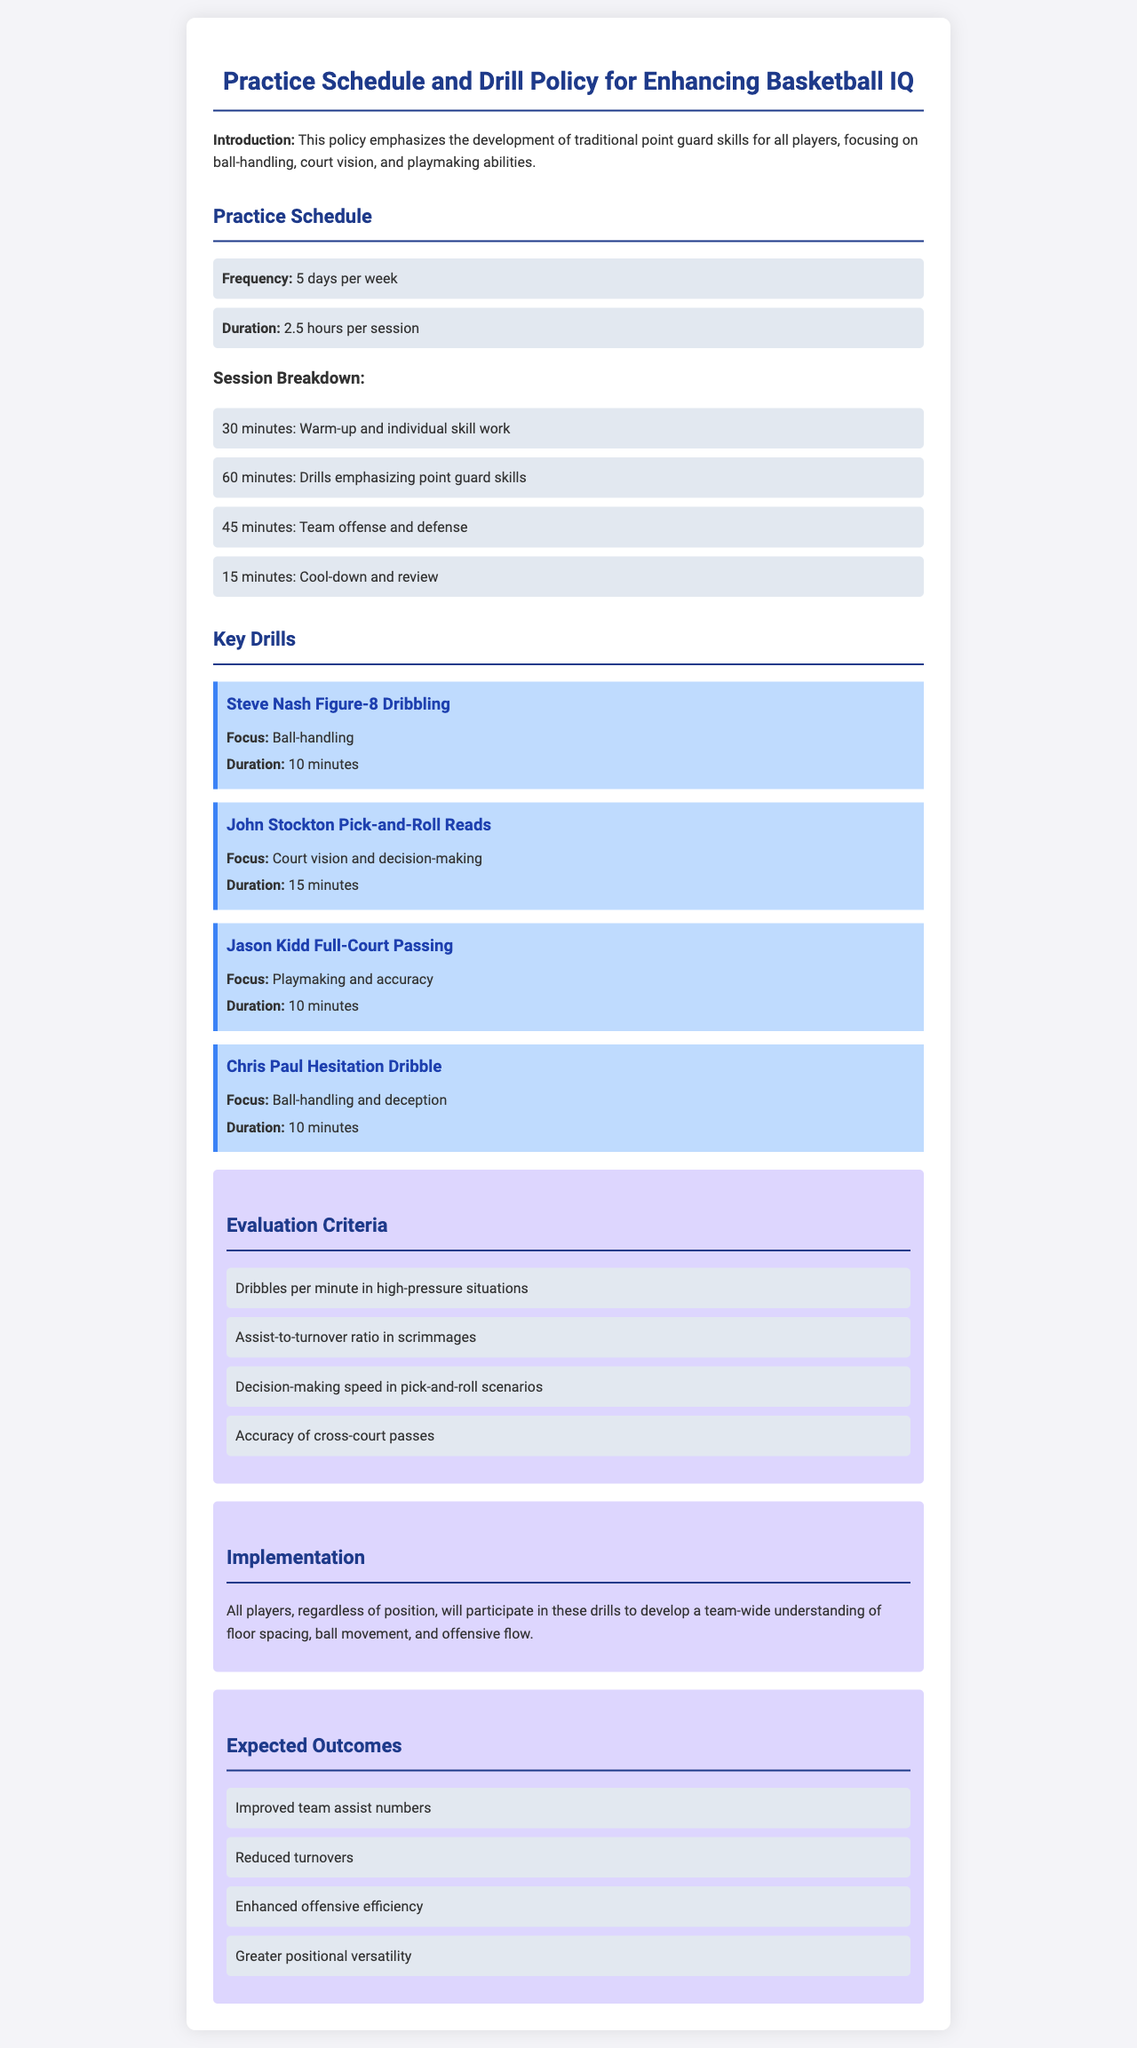how many days per week are practices held? The document states that practices are held 5 days a week.
Answer: 5 days what is the duration of each practice session? The duration of each practice session is 2.5 hours.
Answer: 2.5 hours which drill focuses on ball-handling? The document mentions "Steve Nash Figure-8 Dribbling" as the drill that focuses on ball-handling.
Answer: Steve Nash Figure-8 Dribbling how long is the "John Stockton Pick-and-Roll Reads" drill? The duration of the "John Stockton Pick-and-Roll Reads" drill is 15 minutes.
Answer: 15 minutes what is one of the evaluation criteria provided? One evaluation criterion listed is "Assist-to-turnover ratio in scrimmages."
Answer: Assist-to-turnover ratio what outcome is expected from this practice policy? An expected outcome mentioned is "Improved team assist numbers."
Answer: Improved team assist numbers which section outlines the implementation strategy? The “Implementation” section details how all players will participate in drills.
Answer: Implementation what is the main focus of the practice policy? The main focus of the policy is the development of traditional point guard skills.
Answer: Development of traditional point guard skills how much time is allocated for warm-up and individual skill work? The time allocated for warm-up and individual skill work is 30 minutes.
Answer: 30 minutes 